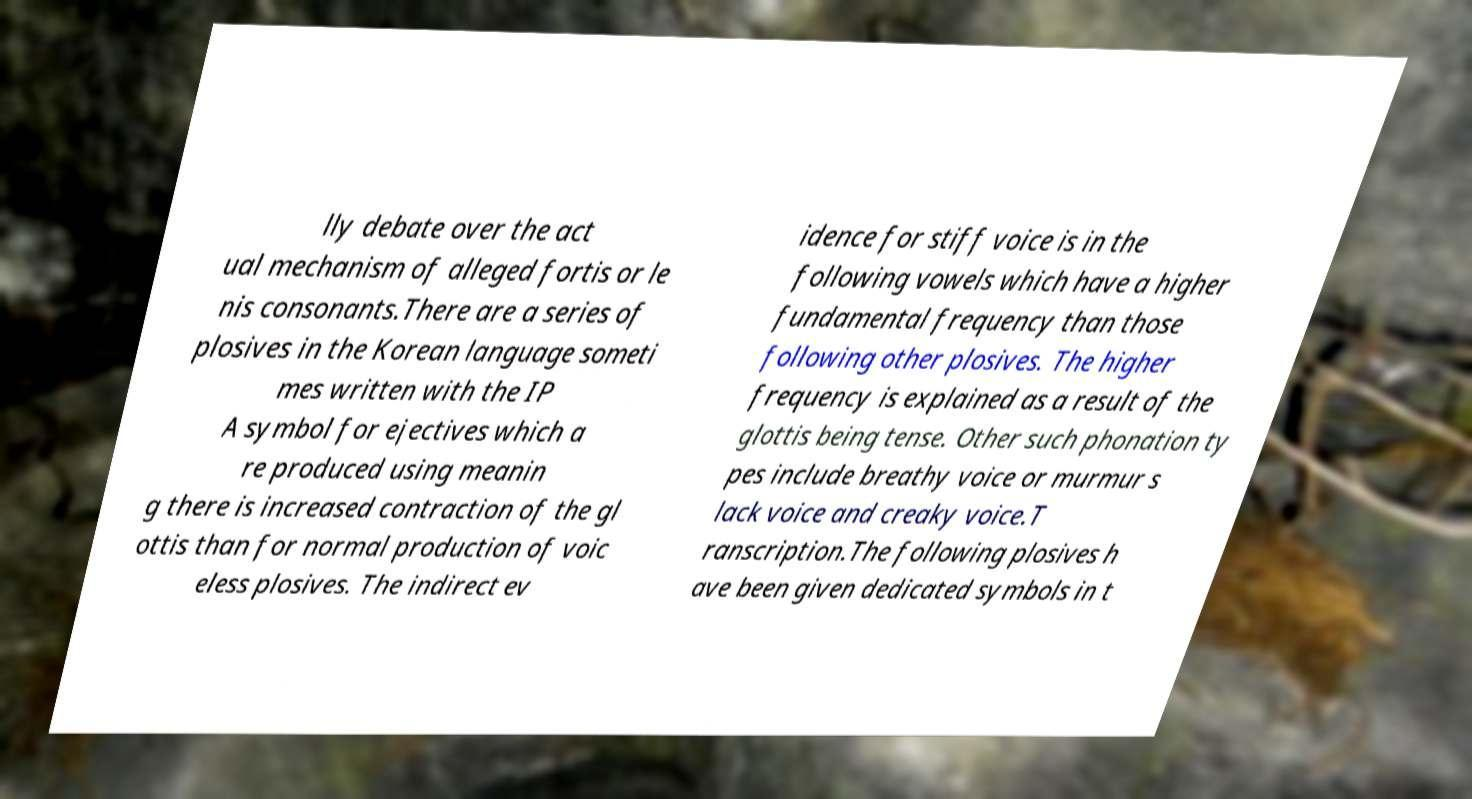Could you assist in decoding the text presented in this image and type it out clearly? lly debate over the act ual mechanism of alleged fortis or le nis consonants.There are a series of plosives in the Korean language someti mes written with the IP A symbol for ejectives which a re produced using meanin g there is increased contraction of the gl ottis than for normal production of voic eless plosives. The indirect ev idence for stiff voice is in the following vowels which have a higher fundamental frequency than those following other plosives. The higher frequency is explained as a result of the glottis being tense. Other such phonation ty pes include breathy voice or murmur s lack voice and creaky voice.T ranscription.The following plosives h ave been given dedicated symbols in t 